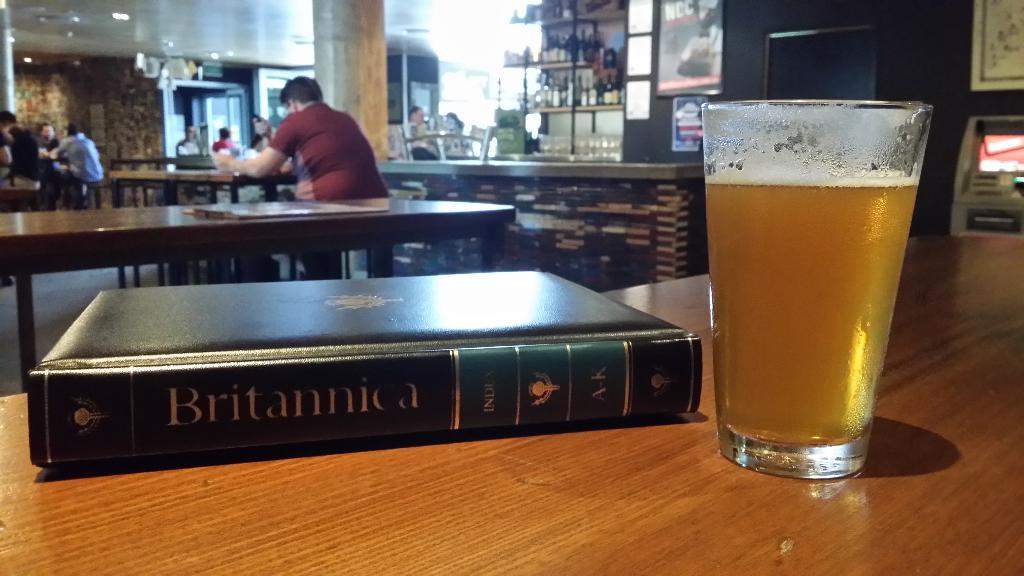<image>
Render a clear and concise summary of the photo. A glass with beer in it and a book titled Britannia. 